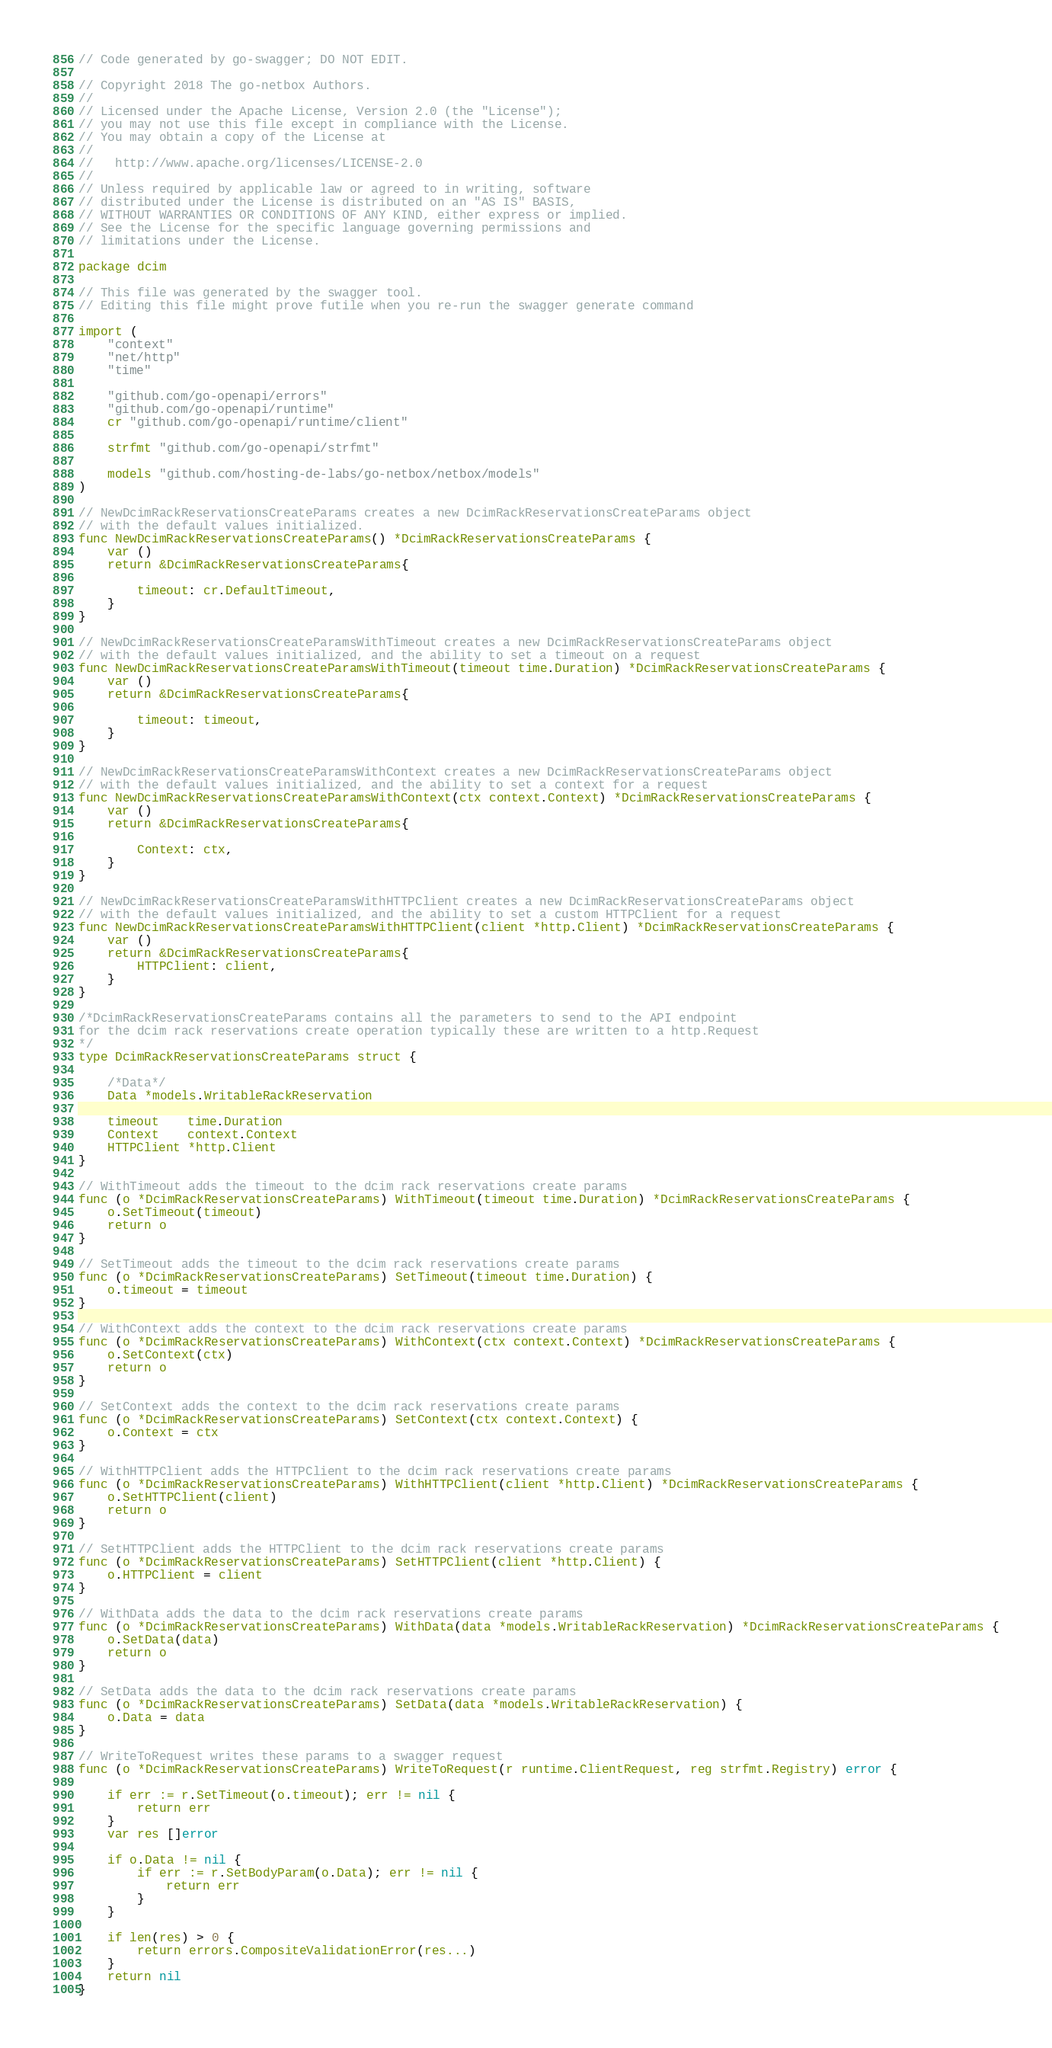Convert code to text. <code><loc_0><loc_0><loc_500><loc_500><_Go_>// Code generated by go-swagger; DO NOT EDIT.

// Copyright 2018 The go-netbox Authors.
//
// Licensed under the Apache License, Version 2.0 (the "License");
// you may not use this file except in compliance with the License.
// You may obtain a copy of the License at
//
//   http://www.apache.org/licenses/LICENSE-2.0
//
// Unless required by applicable law or agreed to in writing, software
// distributed under the License is distributed on an "AS IS" BASIS,
// WITHOUT WARRANTIES OR CONDITIONS OF ANY KIND, either express or implied.
// See the License for the specific language governing permissions and
// limitations under the License.

package dcim

// This file was generated by the swagger tool.
// Editing this file might prove futile when you re-run the swagger generate command

import (
	"context"
	"net/http"
	"time"

	"github.com/go-openapi/errors"
	"github.com/go-openapi/runtime"
	cr "github.com/go-openapi/runtime/client"

	strfmt "github.com/go-openapi/strfmt"

	models "github.com/hosting-de-labs/go-netbox/netbox/models"
)

// NewDcimRackReservationsCreateParams creates a new DcimRackReservationsCreateParams object
// with the default values initialized.
func NewDcimRackReservationsCreateParams() *DcimRackReservationsCreateParams {
	var ()
	return &DcimRackReservationsCreateParams{

		timeout: cr.DefaultTimeout,
	}
}

// NewDcimRackReservationsCreateParamsWithTimeout creates a new DcimRackReservationsCreateParams object
// with the default values initialized, and the ability to set a timeout on a request
func NewDcimRackReservationsCreateParamsWithTimeout(timeout time.Duration) *DcimRackReservationsCreateParams {
	var ()
	return &DcimRackReservationsCreateParams{

		timeout: timeout,
	}
}

// NewDcimRackReservationsCreateParamsWithContext creates a new DcimRackReservationsCreateParams object
// with the default values initialized, and the ability to set a context for a request
func NewDcimRackReservationsCreateParamsWithContext(ctx context.Context) *DcimRackReservationsCreateParams {
	var ()
	return &DcimRackReservationsCreateParams{

		Context: ctx,
	}
}

// NewDcimRackReservationsCreateParamsWithHTTPClient creates a new DcimRackReservationsCreateParams object
// with the default values initialized, and the ability to set a custom HTTPClient for a request
func NewDcimRackReservationsCreateParamsWithHTTPClient(client *http.Client) *DcimRackReservationsCreateParams {
	var ()
	return &DcimRackReservationsCreateParams{
		HTTPClient: client,
	}
}

/*DcimRackReservationsCreateParams contains all the parameters to send to the API endpoint
for the dcim rack reservations create operation typically these are written to a http.Request
*/
type DcimRackReservationsCreateParams struct {

	/*Data*/
	Data *models.WritableRackReservation

	timeout    time.Duration
	Context    context.Context
	HTTPClient *http.Client
}

// WithTimeout adds the timeout to the dcim rack reservations create params
func (o *DcimRackReservationsCreateParams) WithTimeout(timeout time.Duration) *DcimRackReservationsCreateParams {
	o.SetTimeout(timeout)
	return o
}

// SetTimeout adds the timeout to the dcim rack reservations create params
func (o *DcimRackReservationsCreateParams) SetTimeout(timeout time.Duration) {
	o.timeout = timeout
}

// WithContext adds the context to the dcim rack reservations create params
func (o *DcimRackReservationsCreateParams) WithContext(ctx context.Context) *DcimRackReservationsCreateParams {
	o.SetContext(ctx)
	return o
}

// SetContext adds the context to the dcim rack reservations create params
func (o *DcimRackReservationsCreateParams) SetContext(ctx context.Context) {
	o.Context = ctx
}

// WithHTTPClient adds the HTTPClient to the dcim rack reservations create params
func (o *DcimRackReservationsCreateParams) WithHTTPClient(client *http.Client) *DcimRackReservationsCreateParams {
	o.SetHTTPClient(client)
	return o
}

// SetHTTPClient adds the HTTPClient to the dcim rack reservations create params
func (o *DcimRackReservationsCreateParams) SetHTTPClient(client *http.Client) {
	o.HTTPClient = client
}

// WithData adds the data to the dcim rack reservations create params
func (o *DcimRackReservationsCreateParams) WithData(data *models.WritableRackReservation) *DcimRackReservationsCreateParams {
	o.SetData(data)
	return o
}

// SetData adds the data to the dcim rack reservations create params
func (o *DcimRackReservationsCreateParams) SetData(data *models.WritableRackReservation) {
	o.Data = data
}

// WriteToRequest writes these params to a swagger request
func (o *DcimRackReservationsCreateParams) WriteToRequest(r runtime.ClientRequest, reg strfmt.Registry) error {

	if err := r.SetTimeout(o.timeout); err != nil {
		return err
	}
	var res []error

	if o.Data != nil {
		if err := r.SetBodyParam(o.Data); err != nil {
			return err
		}
	}

	if len(res) > 0 {
		return errors.CompositeValidationError(res...)
	}
	return nil
}
</code> 